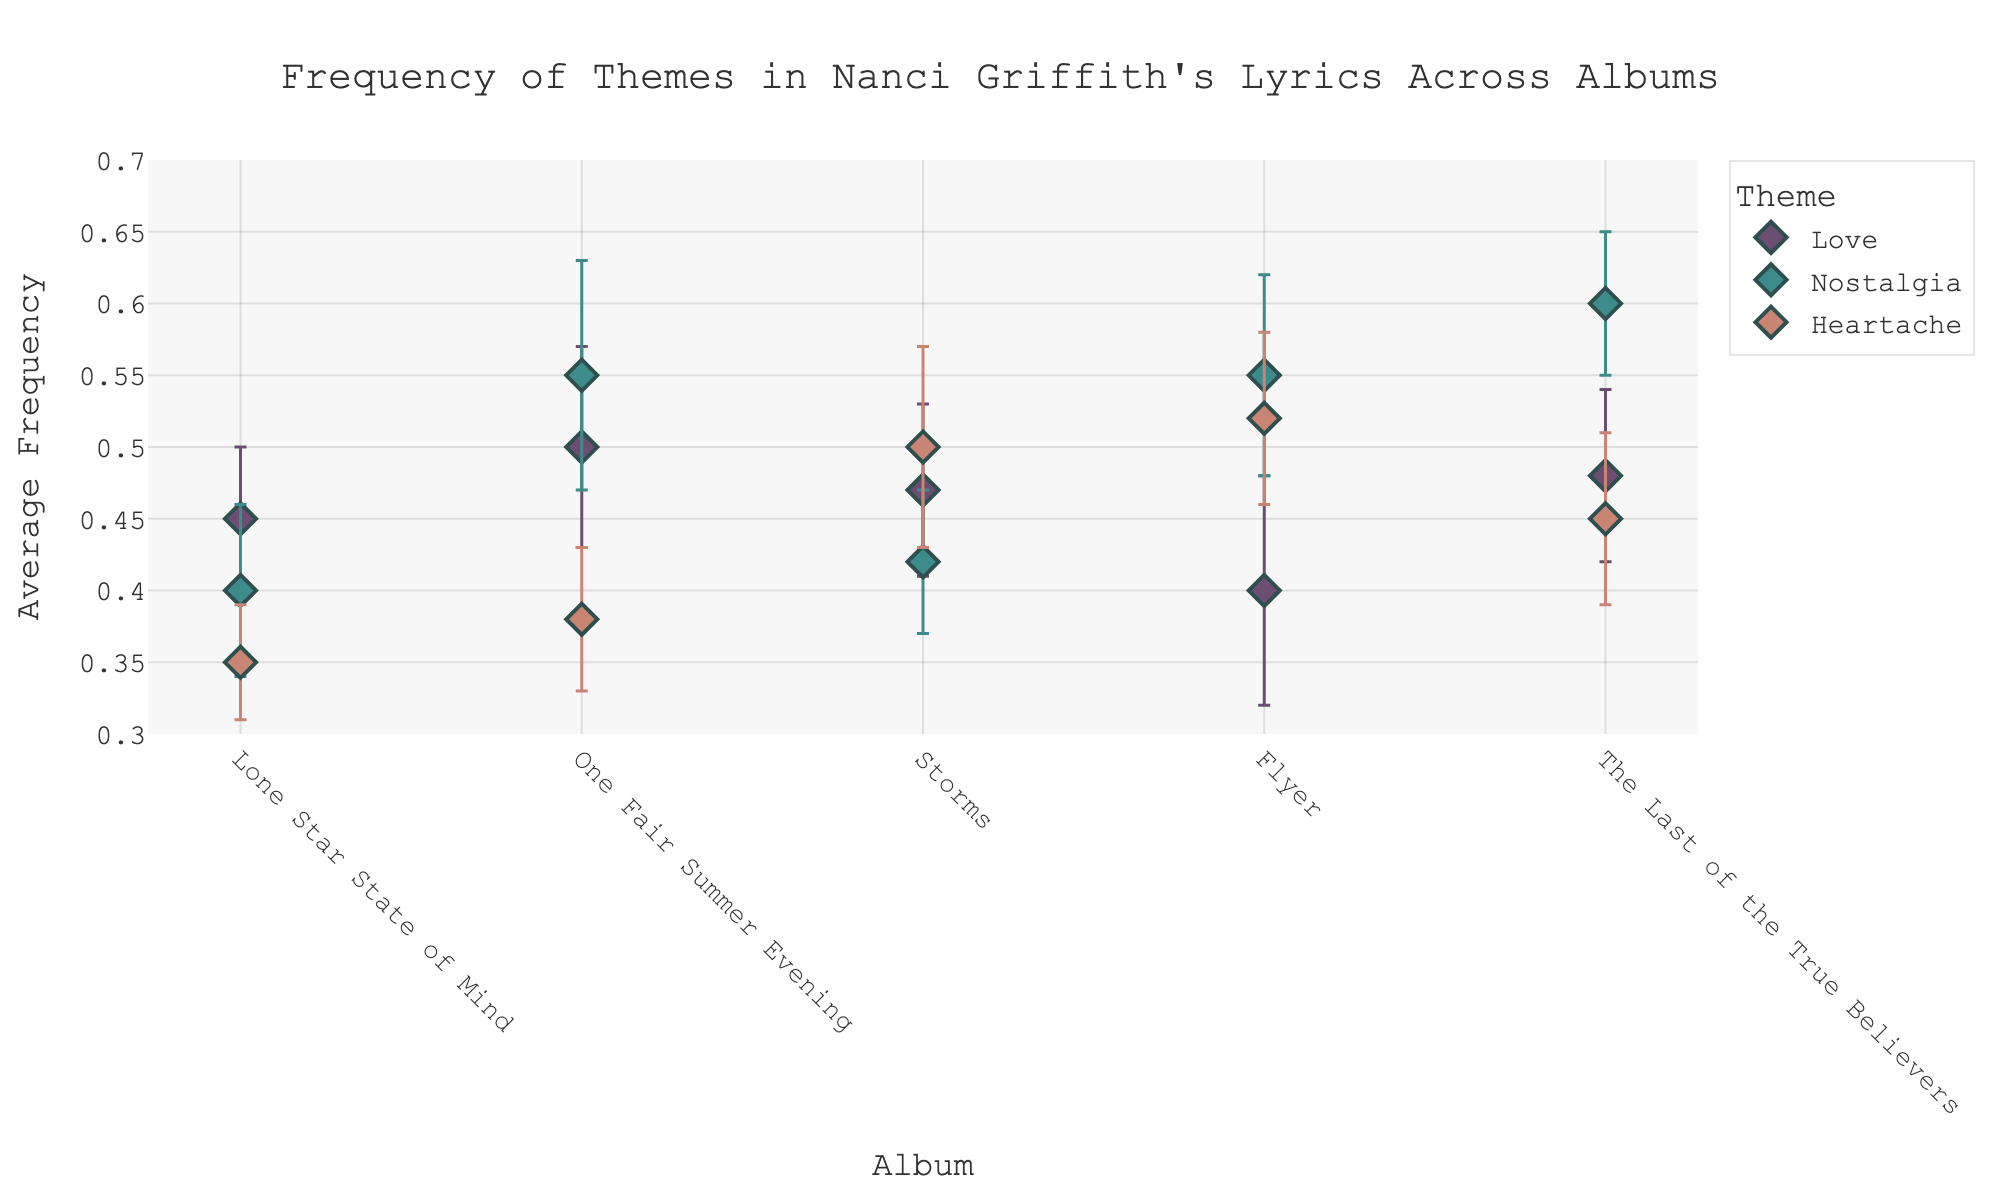What is the title of the plot? The title of the plot is located at the top center of the figure and is formatted in a larger, bold font.
Answer: Frequency of Themes in Nanci Griffith's Lyrics Across Albums How many themes are displayed in the plot? Three distinct themes can be identified by looking at the legend on the right side of the figure.
Answer: Three Which album has the highest average frequency for the "Nostalgia" theme? By comparing the average frequencies on the y-axis for the "Nostalgia" theme across all albums, it is clear that "The Last of the True Believers" has the highest value.
Answer: The Last of the True Believers Between the albums "Storms" and "Flyer," which one has a higher average frequency for the "Love" theme? Checking the y-axis values for the "Love" theme markers, "Storms" has an average frequency of 0.47, while "Flyer" has an average frequency of 0.40.
Answer: Storms Which album has the smallest standard deviation for the "Heartache" theme? By examining the error bars for the "Heartache" theme in each album, "Lone Star State of Mind" has the smallest error bar indicating the smallest standard deviation.
Answer: Lone Star State of Mind On which album is the average frequency of the "Heartache" theme the highest, and what is that value? Looking at the data points on the y-axis for the "Heartache" theme across each album, "Flyer" has the highest average frequency, which is 0.52.
Answer: Flyer, 0.52 What is the difference in average frequency of the "Nostalgia" theme between "One Fair Summer Evening" and "Lone Star State of Mind"? The average frequency for "Nostalgia" in "One Fair Summer Evening" is 0.55 and in "Lone Star State of Mind" it is 0.40. Subtracting them gives 0.55 - 0.40.
Answer: 0.15 Which theme has the most consistent average frequency across all albums, and how can you tell? The "Love" theme has the most consistent average frequency as indicated by its relatively small variation in error bars across all albums compared to the other themes.
Answer: Love In "Storms," which theme has the largest standard deviation, and what is it? Reviewing the error bars for each theme in the "Storms" album, the "Heartache" theme has the largest standard deviation of 0.07.
Answer: Heartache, 0.07 